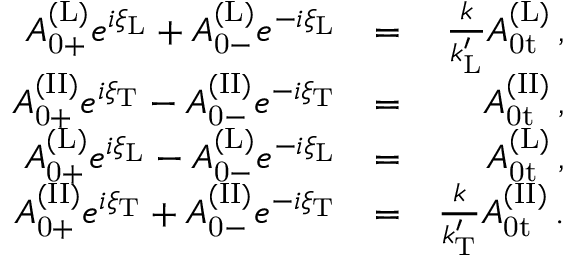<formula> <loc_0><loc_0><loc_500><loc_500>\begin{array} { r l r } { A _ { 0 + } ^ { ( L ) } e ^ { i \xi _ { L } } + A _ { 0 - } ^ { ( L ) } e ^ { - i \xi _ { L } } } & { = } & { \frac { k } { k _ { L } ^ { \prime } } A _ { 0 t } ^ { ( L ) } \, , } \\ { A _ { 0 + } ^ { ( I I ) } e ^ { i \xi _ { T } } - A _ { 0 - } ^ { ( I I ) } e ^ { - i \xi _ { T } } } & { = } & { A _ { 0 t } ^ { ( I I ) } \, , } \\ { A _ { 0 + } ^ { ( L ) } e ^ { i \xi _ { L } } - A _ { 0 - } ^ { ( L ) } e ^ { - i \xi _ { L } } } & { = } & { A _ { 0 t } ^ { ( L ) } \, , } \\ { A _ { 0 + } ^ { ( I I ) } e ^ { i \xi _ { T } } + A _ { 0 - } ^ { ( I I ) } e ^ { - i \xi _ { T } } } & { = } & { \frac { k } { k _ { T } ^ { \prime } } A _ { 0 t } ^ { ( I I ) } \, . } \end{array}</formula> 